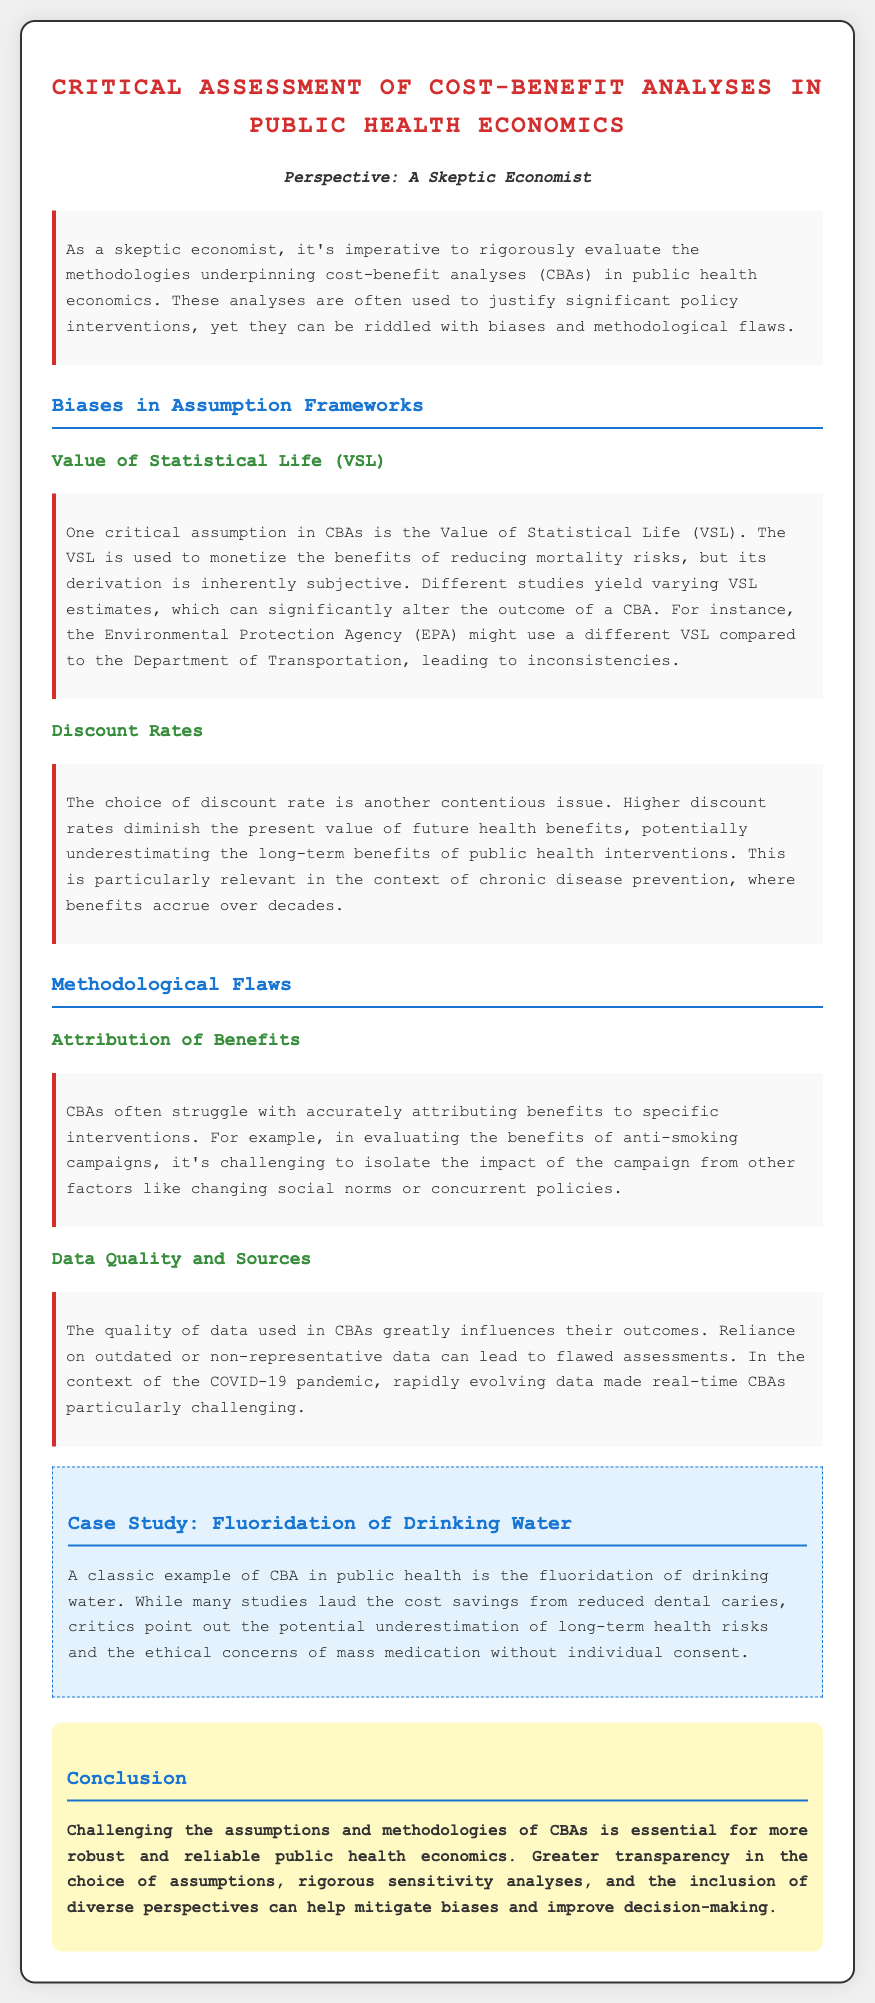What is the title of the document? The title is found at the top of the document, indicating the main topic covered.
Answer: Critical Assessment of Cost-Benefit Analyses in Public Health Economics Who is the perspective of the document? The document introduces a specific viewpoint which is stated in the persona section.
Answer: A Skeptic Economist What assumption is critically evaluated in the context of cost-benefit analyses? One key assumption discussed is highlighted in the section on biases, discussing its implications.
Answer: Value of Statistical Life (VSL) What major issue does the choice of discount rates lead to in CBAs? The impact of discount rates on evaluations is explicitly stated in the associated content section.
Answer: Underestimating long-term benefits What is mentioned as a methodological flaw in CBAs? The text identifies several flaws, specifically emphasizing how benefits can be inaccurately assessed.
Answer: Attribution of Benefits What is the topic of the case study included in the document? The case study section allows for specific public health interventions to be reviewed, focusing on one method.
Answer: Fluoridation of Drinking Water What is emphasized as essential for improving public health economics? The conclusion summarizes the overall argument for enhancing methodologies in the field.
Answer: Challenging assumptions and methodologies What does the content suggest is an important factor in CBA outcomes? Data quality and its impact on the analysis processes are mentioned explicitly in the discussion sections.
Answer: Data Quality and Sources What ethical concern is raised regarding fluoridation? The case study discusses obligations to individual rights and collective health actions.
Answer: Ethical concerns of mass medication without individual consent 